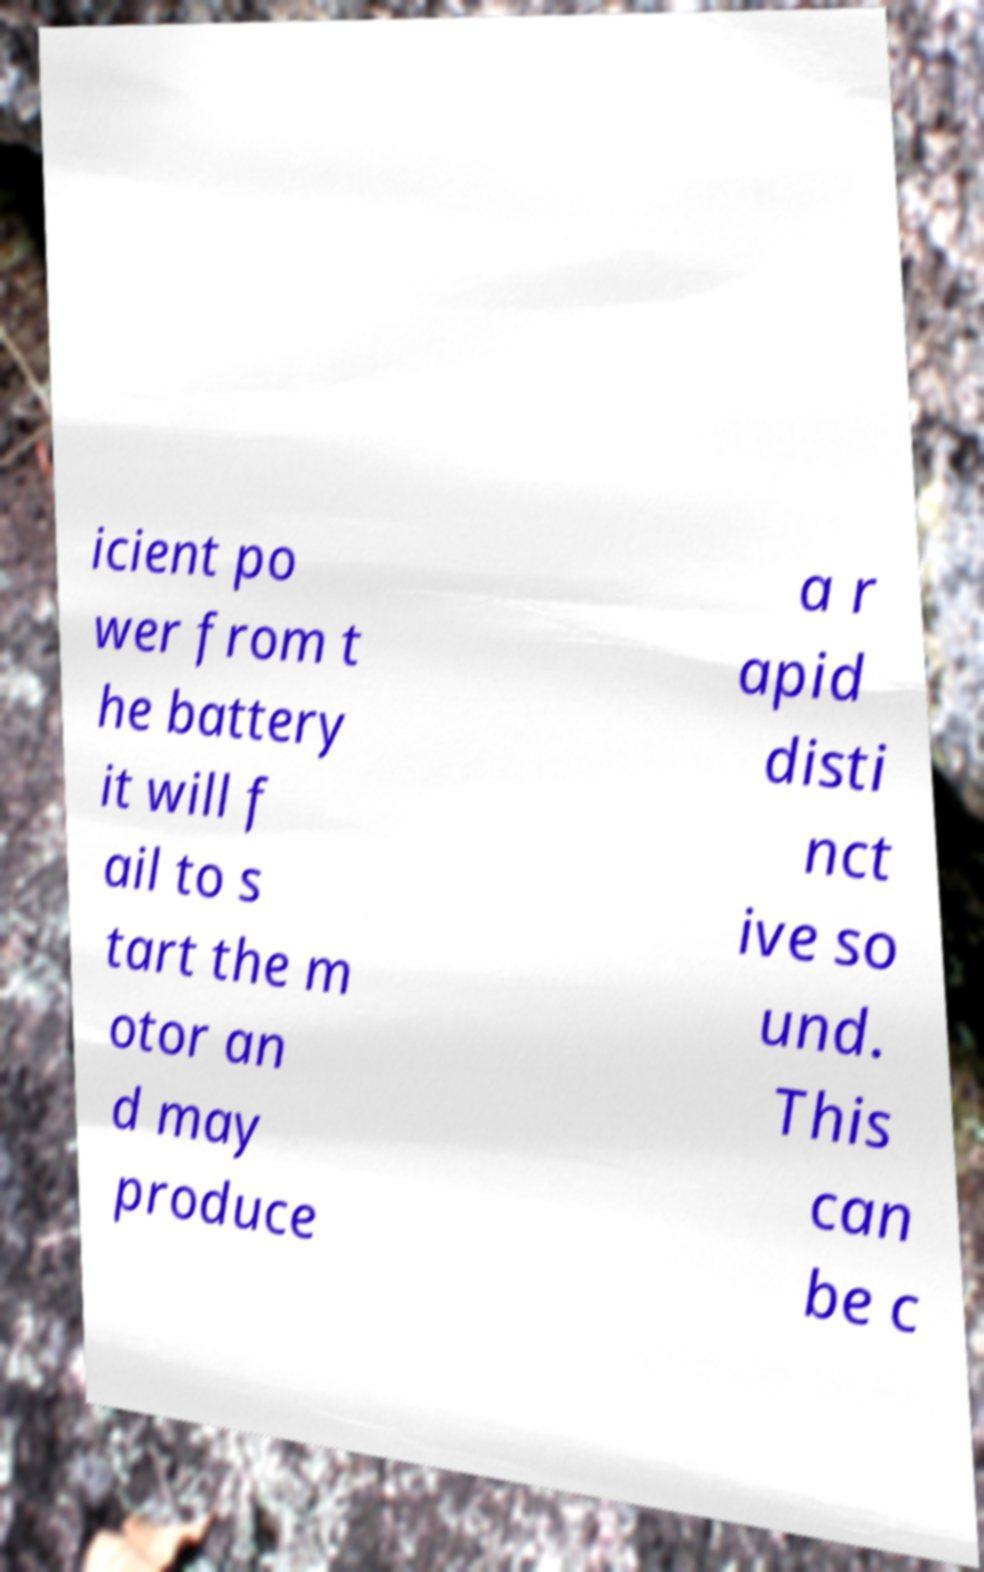Could you extract and type out the text from this image? icient po wer from t he battery it will f ail to s tart the m otor an d may produce a r apid disti nct ive so und. This can be c 